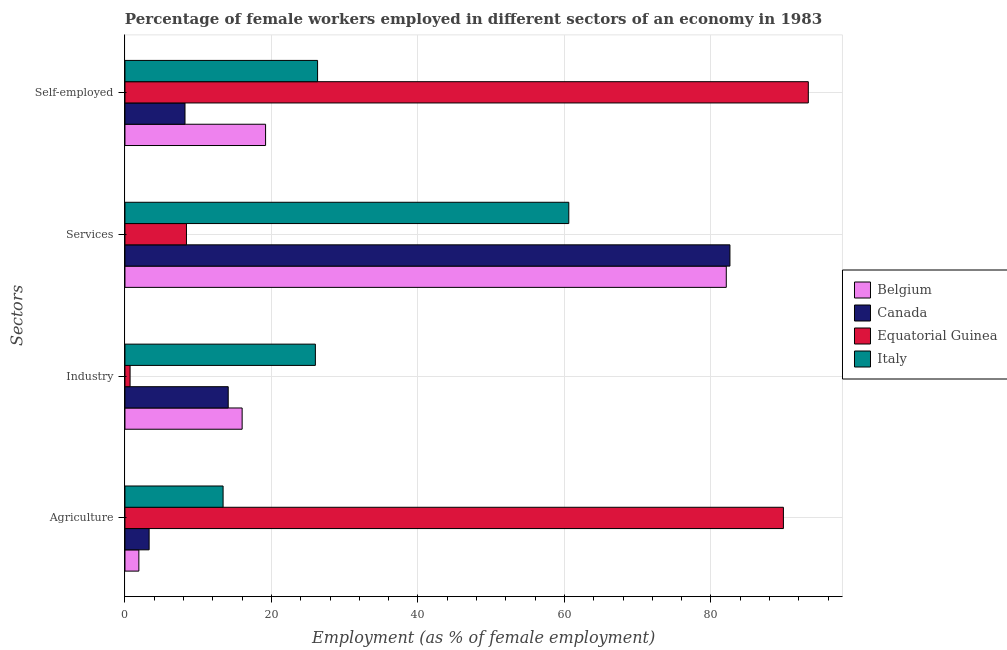How many different coloured bars are there?
Keep it short and to the point. 4. Are the number of bars on each tick of the Y-axis equal?
Ensure brevity in your answer.  Yes. How many bars are there on the 2nd tick from the top?
Your answer should be compact. 4. What is the label of the 4th group of bars from the top?
Offer a very short reply. Agriculture. What is the percentage of female workers in industry in Belgium?
Give a very brief answer. 16. Across all countries, what is the maximum percentage of female workers in services?
Offer a very short reply. 82.6. Across all countries, what is the minimum percentage of self employed female workers?
Provide a short and direct response. 8.2. In which country was the percentage of self employed female workers maximum?
Your response must be concise. Equatorial Guinea. In which country was the percentage of female workers in services minimum?
Keep it short and to the point. Equatorial Guinea. What is the total percentage of female workers in agriculture in the graph?
Keep it short and to the point. 108.5. What is the difference between the percentage of self employed female workers in Italy and that in Canada?
Keep it short and to the point. 18.1. What is the difference between the percentage of female workers in industry in Italy and the percentage of self employed female workers in Equatorial Guinea?
Offer a very short reply. -67.3. What is the average percentage of self employed female workers per country?
Provide a short and direct response. 36.75. What is the difference between the percentage of female workers in agriculture and percentage of female workers in services in Canada?
Provide a short and direct response. -79.3. In how many countries, is the percentage of self employed female workers greater than 8 %?
Provide a succinct answer. 4. What is the ratio of the percentage of female workers in services in Belgium to that in Italy?
Make the answer very short. 1.35. Is the percentage of female workers in services in Canada less than that in Belgium?
Your response must be concise. No. Is the difference between the percentage of self employed female workers in Equatorial Guinea and Belgium greater than the difference between the percentage of female workers in services in Equatorial Guinea and Belgium?
Provide a short and direct response. Yes. What is the difference between the highest and the second highest percentage of self employed female workers?
Make the answer very short. 67. What is the difference between the highest and the lowest percentage of self employed female workers?
Provide a short and direct response. 85.1. Is the sum of the percentage of self employed female workers in Italy and Belgium greater than the maximum percentage of female workers in services across all countries?
Your response must be concise. No. Is it the case that in every country, the sum of the percentage of female workers in services and percentage of self employed female workers is greater than the sum of percentage of female workers in industry and percentage of female workers in agriculture?
Provide a succinct answer. No. Is it the case that in every country, the sum of the percentage of female workers in agriculture and percentage of female workers in industry is greater than the percentage of female workers in services?
Offer a very short reply. No. How many bars are there?
Ensure brevity in your answer.  16. Are all the bars in the graph horizontal?
Make the answer very short. Yes. Are the values on the major ticks of X-axis written in scientific E-notation?
Offer a terse response. No. Does the graph contain grids?
Ensure brevity in your answer.  Yes. Where does the legend appear in the graph?
Your answer should be very brief. Center right. How many legend labels are there?
Provide a succinct answer. 4. How are the legend labels stacked?
Your answer should be very brief. Vertical. What is the title of the graph?
Make the answer very short. Percentage of female workers employed in different sectors of an economy in 1983. What is the label or title of the X-axis?
Provide a succinct answer. Employment (as % of female employment). What is the label or title of the Y-axis?
Keep it short and to the point. Sectors. What is the Employment (as % of female employment) in Belgium in Agriculture?
Your answer should be very brief. 1.9. What is the Employment (as % of female employment) of Canada in Agriculture?
Make the answer very short. 3.3. What is the Employment (as % of female employment) in Equatorial Guinea in Agriculture?
Make the answer very short. 89.9. What is the Employment (as % of female employment) in Italy in Agriculture?
Your answer should be very brief. 13.4. What is the Employment (as % of female employment) of Belgium in Industry?
Your response must be concise. 16. What is the Employment (as % of female employment) in Canada in Industry?
Ensure brevity in your answer.  14.1. What is the Employment (as % of female employment) in Equatorial Guinea in Industry?
Keep it short and to the point. 0.7. What is the Employment (as % of female employment) in Italy in Industry?
Keep it short and to the point. 26. What is the Employment (as % of female employment) in Belgium in Services?
Offer a very short reply. 82.1. What is the Employment (as % of female employment) of Canada in Services?
Offer a very short reply. 82.6. What is the Employment (as % of female employment) of Equatorial Guinea in Services?
Ensure brevity in your answer.  8.4. What is the Employment (as % of female employment) of Italy in Services?
Your answer should be compact. 60.6. What is the Employment (as % of female employment) of Belgium in Self-employed?
Your response must be concise. 19.2. What is the Employment (as % of female employment) of Canada in Self-employed?
Ensure brevity in your answer.  8.2. What is the Employment (as % of female employment) of Equatorial Guinea in Self-employed?
Ensure brevity in your answer.  93.3. What is the Employment (as % of female employment) of Italy in Self-employed?
Provide a succinct answer. 26.3. Across all Sectors, what is the maximum Employment (as % of female employment) in Belgium?
Keep it short and to the point. 82.1. Across all Sectors, what is the maximum Employment (as % of female employment) in Canada?
Offer a very short reply. 82.6. Across all Sectors, what is the maximum Employment (as % of female employment) in Equatorial Guinea?
Provide a short and direct response. 93.3. Across all Sectors, what is the maximum Employment (as % of female employment) of Italy?
Provide a short and direct response. 60.6. Across all Sectors, what is the minimum Employment (as % of female employment) in Belgium?
Give a very brief answer. 1.9. Across all Sectors, what is the minimum Employment (as % of female employment) in Canada?
Provide a short and direct response. 3.3. Across all Sectors, what is the minimum Employment (as % of female employment) of Equatorial Guinea?
Offer a terse response. 0.7. Across all Sectors, what is the minimum Employment (as % of female employment) of Italy?
Provide a short and direct response. 13.4. What is the total Employment (as % of female employment) in Belgium in the graph?
Your answer should be very brief. 119.2. What is the total Employment (as % of female employment) of Canada in the graph?
Offer a very short reply. 108.2. What is the total Employment (as % of female employment) in Equatorial Guinea in the graph?
Your answer should be very brief. 192.3. What is the total Employment (as % of female employment) in Italy in the graph?
Your response must be concise. 126.3. What is the difference between the Employment (as % of female employment) of Belgium in Agriculture and that in Industry?
Provide a short and direct response. -14.1. What is the difference between the Employment (as % of female employment) in Canada in Agriculture and that in Industry?
Ensure brevity in your answer.  -10.8. What is the difference between the Employment (as % of female employment) of Equatorial Guinea in Agriculture and that in Industry?
Provide a short and direct response. 89.2. What is the difference between the Employment (as % of female employment) in Belgium in Agriculture and that in Services?
Keep it short and to the point. -80.2. What is the difference between the Employment (as % of female employment) in Canada in Agriculture and that in Services?
Give a very brief answer. -79.3. What is the difference between the Employment (as % of female employment) in Equatorial Guinea in Agriculture and that in Services?
Your response must be concise. 81.5. What is the difference between the Employment (as % of female employment) of Italy in Agriculture and that in Services?
Offer a terse response. -47.2. What is the difference between the Employment (as % of female employment) of Belgium in Agriculture and that in Self-employed?
Your response must be concise. -17.3. What is the difference between the Employment (as % of female employment) of Canada in Agriculture and that in Self-employed?
Make the answer very short. -4.9. What is the difference between the Employment (as % of female employment) of Belgium in Industry and that in Services?
Your response must be concise. -66.1. What is the difference between the Employment (as % of female employment) in Canada in Industry and that in Services?
Your answer should be very brief. -68.5. What is the difference between the Employment (as % of female employment) of Equatorial Guinea in Industry and that in Services?
Keep it short and to the point. -7.7. What is the difference between the Employment (as % of female employment) of Italy in Industry and that in Services?
Your answer should be compact. -34.6. What is the difference between the Employment (as % of female employment) in Belgium in Industry and that in Self-employed?
Give a very brief answer. -3.2. What is the difference between the Employment (as % of female employment) of Equatorial Guinea in Industry and that in Self-employed?
Your answer should be compact. -92.6. What is the difference between the Employment (as % of female employment) in Italy in Industry and that in Self-employed?
Make the answer very short. -0.3. What is the difference between the Employment (as % of female employment) in Belgium in Services and that in Self-employed?
Provide a short and direct response. 62.9. What is the difference between the Employment (as % of female employment) of Canada in Services and that in Self-employed?
Offer a very short reply. 74.4. What is the difference between the Employment (as % of female employment) in Equatorial Guinea in Services and that in Self-employed?
Your response must be concise. -84.9. What is the difference between the Employment (as % of female employment) in Italy in Services and that in Self-employed?
Give a very brief answer. 34.3. What is the difference between the Employment (as % of female employment) in Belgium in Agriculture and the Employment (as % of female employment) in Canada in Industry?
Your response must be concise. -12.2. What is the difference between the Employment (as % of female employment) of Belgium in Agriculture and the Employment (as % of female employment) of Equatorial Guinea in Industry?
Keep it short and to the point. 1.2. What is the difference between the Employment (as % of female employment) in Belgium in Agriculture and the Employment (as % of female employment) in Italy in Industry?
Provide a succinct answer. -24.1. What is the difference between the Employment (as % of female employment) in Canada in Agriculture and the Employment (as % of female employment) in Italy in Industry?
Your answer should be very brief. -22.7. What is the difference between the Employment (as % of female employment) of Equatorial Guinea in Agriculture and the Employment (as % of female employment) of Italy in Industry?
Keep it short and to the point. 63.9. What is the difference between the Employment (as % of female employment) of Belgium in Agriculture and the Employment (as % of female employment) of Canada in Services?
Provide a short and direct response. -80.7. What is the difference between the Employment (as % of female employment) of Belgium in Agriculture and the Employment (as % of female employment) of Italy in Services?
Your response must be concise. -58.7. What is the difference between the Employment (as % of female employment) of Canada in Agriculture and the Employment (as % of female employment) of Italy in Services?
Provide a short and direct response. -57.3. What is the difference between the Employment (as % of female employment) of Equatorial Guinea in Agriculture and the Employment (as % of female employment) of Italy in Services?
Make the answer very short. 29.3. What is the difference between the Employment (as % of female employment) in Belgium in Agriculture and the Employment (as % of female employment) in Canada in Self-employed?
Give a very brief answer. -6.3. What is the difference between the Employment (as % of female employment) in Belgium in Agriculture and the Employment (as % of female employment) in Equatorial Guinea in Self-employed?
Ensure brevity in your answer.  -91.4. What is the difference between the Employment (as % of female employment) in Belgium in Agriculture and the Employment (as % of female employment) in Italy in Self-employed?
Provide a short and direct response. -24.4. What is the difference between the Employment (as % of female employment) of Canada in Agriculture and the Employment (as % of female employment) of Equatorial Guinea in Self-employed?
Give a very brief answer. -90. What is the difference between the Employment (as % of female employment) in Equatorial Guinea in Agriculture and the Employment (as % of female employment) in Italy in Self-employed?
Ensure brevity in your answer.  63.6. What is the difference between the Employment (as % of female employment) of Belgium in Industry and the Employment (as % of female employment) of Canada in Services?
Keep it short and to the point. -66.6. What is the difference between the Employment (as % of female employment) of Belgium in Industry and the Employment (as % of female employment) of Equatorial Guinea in Services?
Make the answer very short. 7.6. What is the difference between the Employment (as % of female employment) of Belgium in Industry and the Employment (as % of female employment) of Italy in Services?
Ensure brevity in your answer.  -44.6. What is the difference between the Employment (as % of female employment) in Canada in Industry and the Employment (as % of female employment) in Equatorial Guinea in Services?
Keep it short and to the point. 5.7. What is the difference between the Employment (as % of female employment) in Canada in Industry and the Employment (as % of female employment) in Italy in Services?
Keep it short and to the point. -46.5. What is the difference between the Employment (as % of female employment) in Equatorial Guinea in Industry and the Employment (as % of female employment) in Italy in Services?
Ensure brevity in your answer.  -59.9. What is the difference between the Employment (as % of female employment) of Belgium in Industry and the Employment (as % of female employment) of Equatorial Guinea in Self-employed?
Offer a terse response. -77.3. What is the difference between the Employment (as % of female employment) in Belgium in Industry and the Employment (as % of female employment) in Italy in Self-employed?
Ensure brevity in your answer.  -10.3. What is the difference between the Employment (as % of female employment) of Canada in Industry and the Employment (as % of female employment) of Equatorial Guinea in Self-employed?
Offer a terse response. -79.2. What is the difference between the Employment (as % of female employment) in Equatorial Guinea in Industry and the Employment (as % of female employment) in Italy in Self-employed?
Ensure brevity in your answer.  -25.6. What is the difference between the Employment (as % of female employment) of Belgium in Services and the Employment (as % of female employment) of Canada in Self-employed?
Ensure brevity in your answer.  73.9. What is the difference between the Employment (as % of female employment) in Belgium in Services and the Employment (as % of female employment) in Italy in Self-employed?
Make the answer very short. 55.8. What is the difference between the Employment (as % of female employment) in Canada in Services and the Employment (as % of female employment) in Italy in Self-employed?
Give a very brief answer. 56.3. What is the difference between the Employment (as % of female employment) of Equatorial Guinea in Services and the Employment (as % of female employment) of Italy in Self-employed?
Offer a terse response. -17.9. What is the average Employment (as % of female employment) in Belgium per Sectors?
Offer a terse response. 29.8. What is the average Employment (as % of female employment) of Canada per Sectors?
Provide a short and direct response. 27.05. What is the average Employment (as % of female employment) in Equatorial Guinea per Sectors?
Provide a succinct answer. 48.08. What is the average Employment (as % of female employment) of Italy per Sectors?
Your answer should be compact. 31.57. What is the difference between the Employment (as % of female employment) in Belgium and Employment (as % of female employment) in Canada in Agriculture?
Your answer should be compact. -1.4. What is the difference between the Employment (as % of female employment) in Belgium and Employment (as % of female employment) in Equatorial Guinea in Agriculture?
Provide a succinct answer. -88. What is the difference between the Employment (as % of female employment) in Canada and Employment (as % of female employment) in Equatorial Guinea in Agriculture?
Offer a very short reply. -86.6. What is the difference between the Employment (as % of female employment) of Equatorial Guinea and Employment (as % of female employment) of Italy in Agriculture?
Your response must be concise. 76.5. What is the difference between the Employment (as % of female employment) in Belgium and Employment (as % of female employment) in Canada in Industry?
Your response must be concise. 1.9. What is the difference between the Employment (as % of female employment) in Belgium and Employment (as % of female employment) in Equatorial Guinea in Industry?
Ensure brevity in your answer.  15.3. What is the difference between the Employment (as % of female employment) of Belgium and Employment (as % of female employment) of Italy in Industry?
Keep it short and to the point. -10. What is the difference between the Employment (as % of female employment) of Canada and Employment (as % of female employment) of Italy in Industry?
Provide a short and direct response. -11.9. What is the difference between the Employment (as % of female employment) in Equatorial Guinea and Employment (as % of female employment) in Italy in Industry?
Your answer should be compact. -25.3. What is the difference between the Employment (as % of female employment) in Belgium and Employment (as % of female employment) in Canada in Services?
Offer a very short reply. -0.5. What is the difference between the Employment (as % of female employment) of Belgium and Employment (as % of female employment) of Equatorial Guinea in Services?
Keep it short and to the point. 73.7. What is the difference between the Employment (as % of female employment) in Canada and Employment (as % of female employment) in Equatorial Guinea in Services?
Provide a short and direct response. 74.2. What is the difference between the Employment (as % of female employment) of Equatorial Guinea and Employment (as % of female employment) of Italy in Services?
Give a very brief answer. -52.2. What is the difference between the Employment (as % of female employment) of Belgium and Employment (as % of female employment) of Equatorial Guinea in Self-employed?
Provide a short and direct response. -74.1. What is the difference between the Employment (as % of female employment) of Canada and Employment (as % of female employment) of Equatorial Guinea in Self-employed?
Make the answer very short. -85.1. What is the difference between the Employment (as % of female employment) of Canada and Employment (as % of female employment) of Italy in Self-employed?
Your answer should be compact. -18.1. What is the ratio of the Employment (as % of female employment) of Belgium in Agriculture to that in Industry?
Keep it short and to the point. 0.12. What is the ratio of the Employment (as % of female employment) in Canada in Agriculture to that in Industry?
Your response must be concise. 0.23. What is the ratio of the Employment (as % of female employment) in Equatorial Guinea in Agriculture to that in Industry?
Your response must be concise. 128.43. What is the ratio of the Employment (as % of female employment) of Italy in Agriculture to that in Industry?
Give a very brief answer. 0.52. What is the ratio of the Employment (as % of female employment) of Belgium in Agriculture to that in Services?
Offer a terse response. 0.02. What is the ratio of the Employment (as % of female employment) of Equatorial Guinea in Agriculture to that in Services?
Your answer should be very brief. 10.7. What is the ratio of the Employment (as % of female employment) in Italy in Agriculture to that in Services?
Give a very brief answer. 0.22. What is the ratio of the Employment (as % of female employment) of Belgium in Agriculture to that in Self-employed?
Provide a succinct answer. 0.1. What is the ratio of the Employment (as % of female employment) of Canada in Agriculture to that in Self-employed?
Make the answer very short. 0.4. What is the ratio of the Employment (as % of female employment) of Equatorial Guinea in Agriculture to that in Self-employed?
Ensure brevity in your answer.  0.96. What is the ratio of the Employment (as % of female employment) in Italy in Agriculture to that in Self-employed?
Your response must be concise. 0.51. What is the ratio of the Employment (as % of female employment) in Belgium in Industry to that in Services?
Your response must be concise. 0.19. What is the ratio of the Employment (as % of female employment) of Canada in Industry to that in Services?
Provide a short and direct response. 0.17. What is the ratio of the Employment (as % of female employment) of Equatorial Guinea in Industry to that in Services?
Offer a terse response. 0.08. What is the ratio of the Employment (as % of female employment) in Italy in Industry to that in Services?
Your answer should be compact. 0.43. What is the ratio of the Employment (as % of female employment) of Belgium in Industry to that in Self-employed?
Your answer should be very brief. 0.83. What is the ratio of the Employment (as % of female employment) of Canada in Industry to that in Self-employed?
Offer a terse response. 1.72. What is the ratio of the Employment (as % of female employment) in Equatorial Guinea in Industry to that in Self-employed?
Offer a very short reply. 0.01. What is the ratio of the Employment (as % of female employment) of Italy in Industry to that in Self-employed?
Your answer should be very brief. 0.99. What is the ratio of the Employment (as % of female employment) of Belgium in Services to that in Self-employed?
Your answer should be very brief. 4.28. What is the ratio of the Employment (as % of female employment) in Canada in Services to that in Self-employed?
Offer a terse response. 10.07. What is the ratio of the Employment (as % of female employment) of Equatorial Guinea in Services to that in Self-employed?
Provide a succinct answer. 0.09. What is the ratio of the Employment (as % of female employment) in Italy in Services to that in Self-employed?
Give a very brief answer. 2.3. What is the difference between the highest and the second highest Employment (as % of female employment) in Belgium?
Offer a very short reply. 62.9. What is the difference between the highest and the second highest Employment (as % of female employment) of Canada?
Give a very brief answer. 68.5. What is the difference between the highest and the second highest Employment (as % of female employment) of Italy?
Make the answer very short. 34.3. What is the difference between the highest and the lowest Employment (as % of female employment) of Belgium?
Offer a terse response. 80.2. What is the difference between the highest and the lowest Employment (as % of female employment) of Canada?
Provide a short and direct response. 79.3. What is the difference between the highest and the lowest Employment (as % of female employment) in Equatorial Guinea?
Keep it short and to the point. 92.6. What is the difference between the highest and the lowest Employment (as % of female employment) of Italy?
Give a very brief answer. 47.2. 